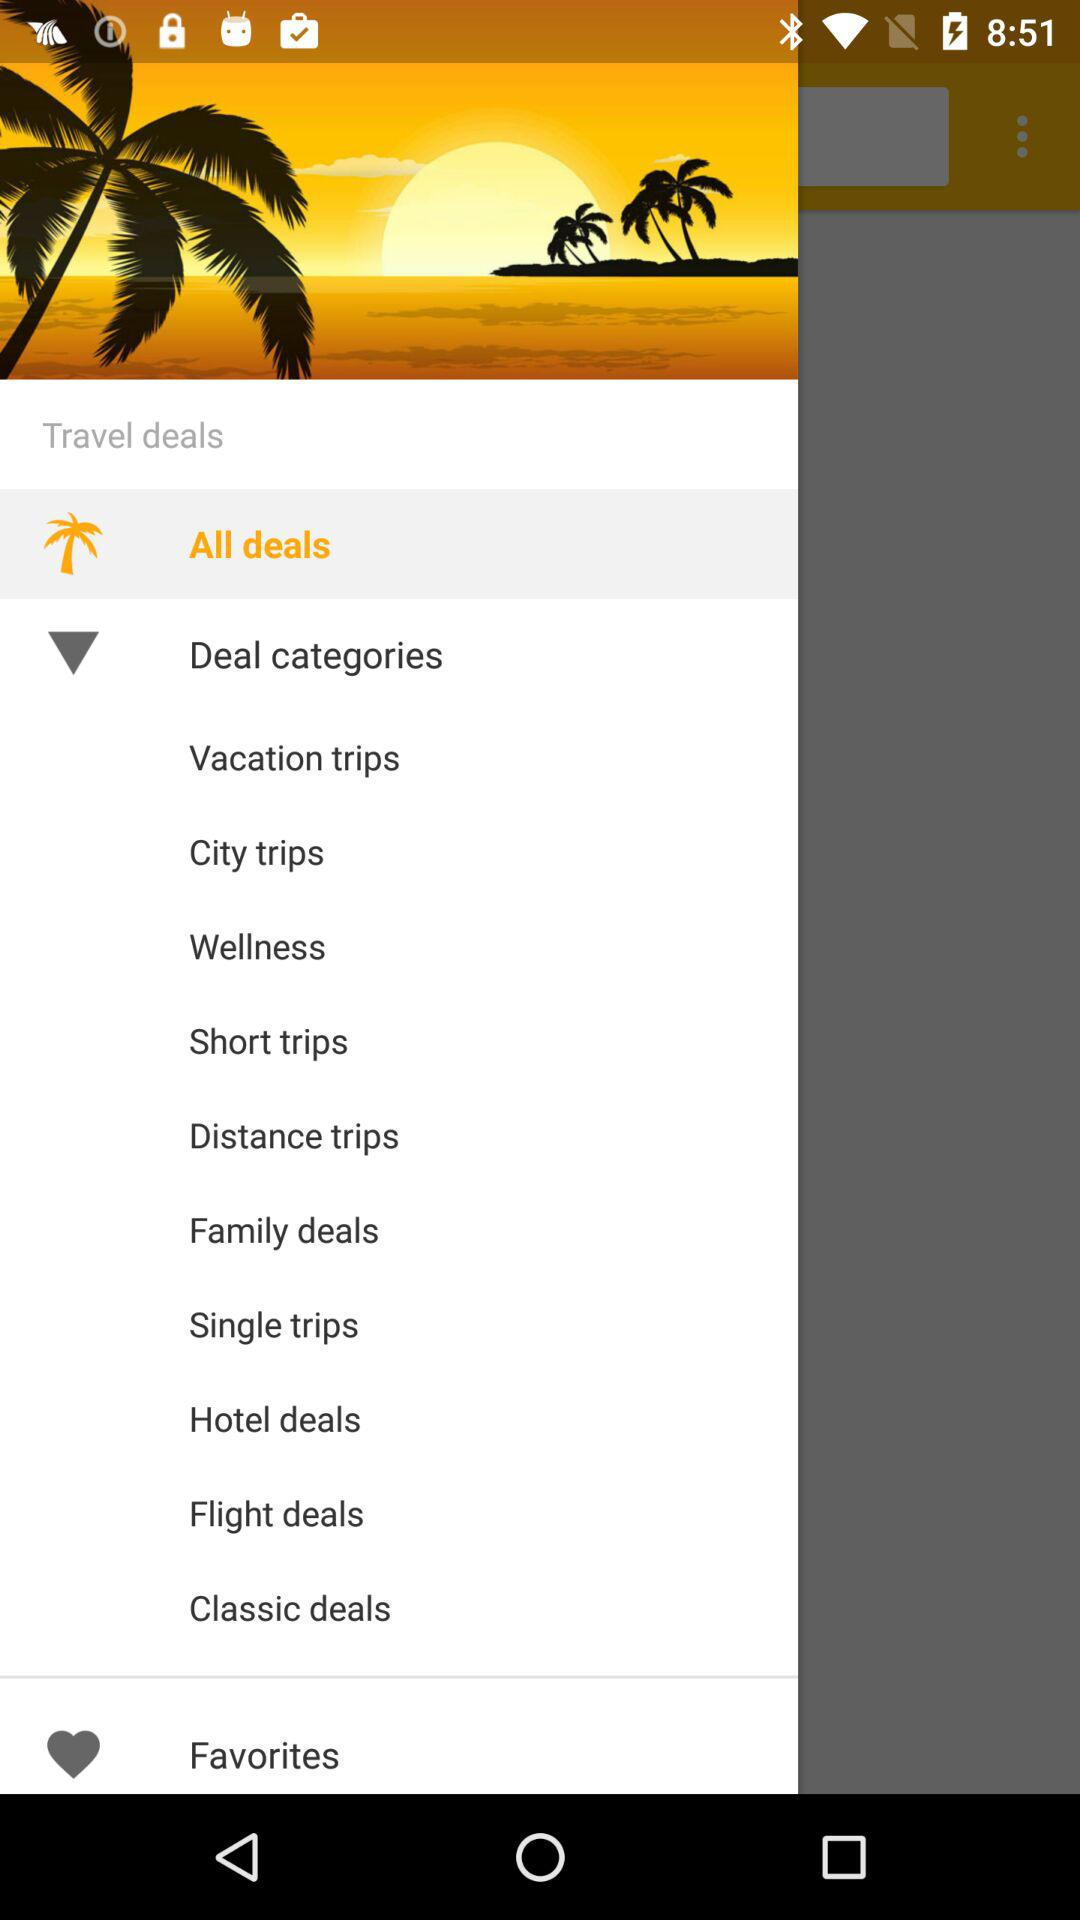How many deal categories are there?
Answer the question using a single word or phrase. 10 